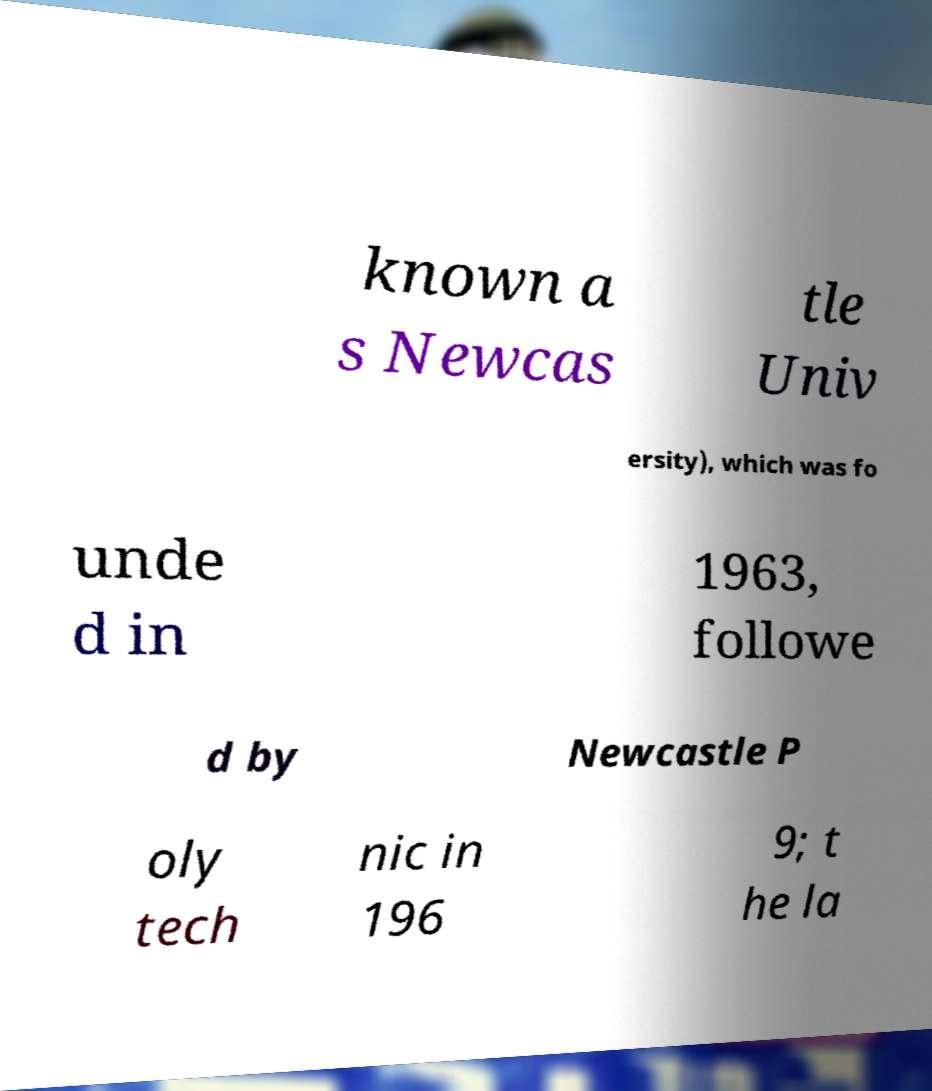Could you assist in decoding the text presented in this image and type it out clearly? known a s Newcas tle Univ ersity), which was fo unde d in 1963, followe d by Newcastle P oly tech nic in 196 9; t he la 